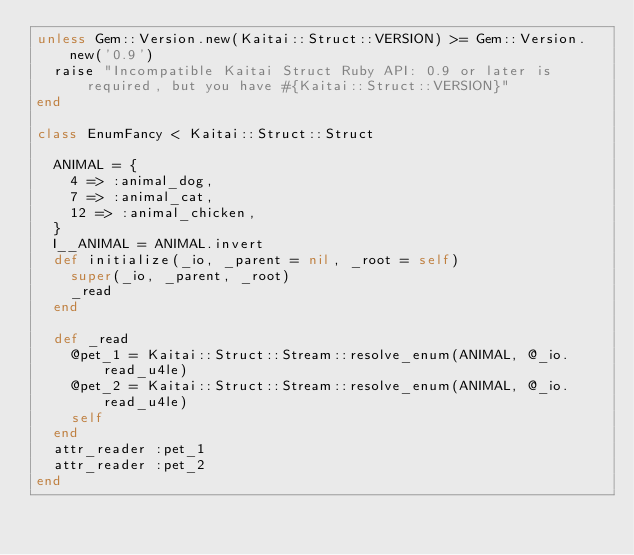Convert code to text. <code><loc_0><loc_0><loc_500><loc_500><_Ruby_>unless Gem::Version.new(Kaitai::Struct::VERSION) >= Gem::Version.new('0.9')
  raise "Incompatible Kaitai Struct Ruby API: 0.9 or later is required, but you have #{Kaitai::Struct::VERSION}"
end

class EnumFancy < Kaitai::Struct::Struct

  ANIMAL = {
    4 => :animal_dog,
    7 => :animal_cat,
    12 => :animal_chicken,
  }
  I__ANIMAL = ANIMAL.invert
  def initialize(_io, _parent = nil, _root = self)
    super(_io, _parent, _root)
    _read
  end

  def _read
    @pet_1 = Kaitai::Struct::Stream::resolve_enum(ANIMAL, @_io.read_u4le)
    @pet_2 = Kaitai::Struct::Stream::resolve_enum(ANIMAL, @_io.read_u4le)
    self
  end
  attr_reader :pet_1
  attr_reader :pet_2
end
</code> 